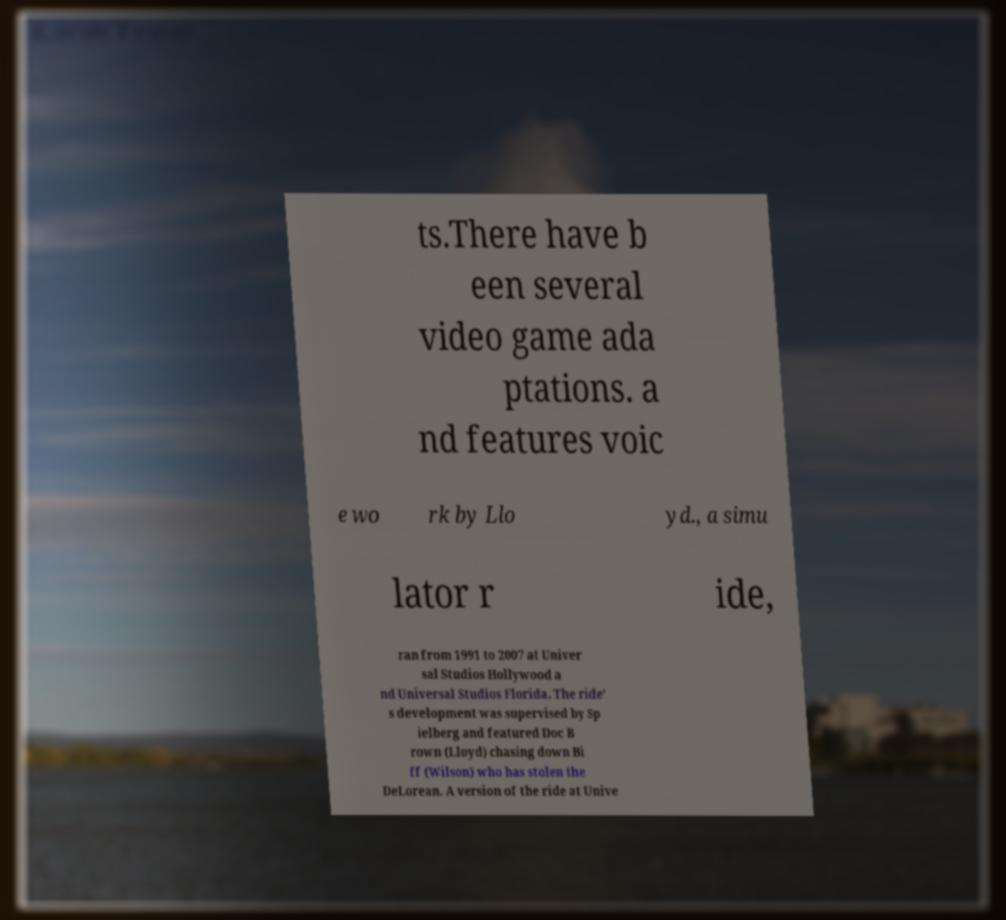I need the written content from this picture converted into text. Can you do that? ts.There have b een several video game ada ptations. a nd features voic e wo rk by Llo yd., a simu lator r ide, ran from 1991 to 2007 at Univer sal Studios Hollywood a nd Universal Studios Florida. The ride' s development was supervised by Sp ielberg and featured Doc B rown (Lloyd) chasing down Bi ff (Wilson) who has stolen the DeLorean. A version of the ride at Unive 